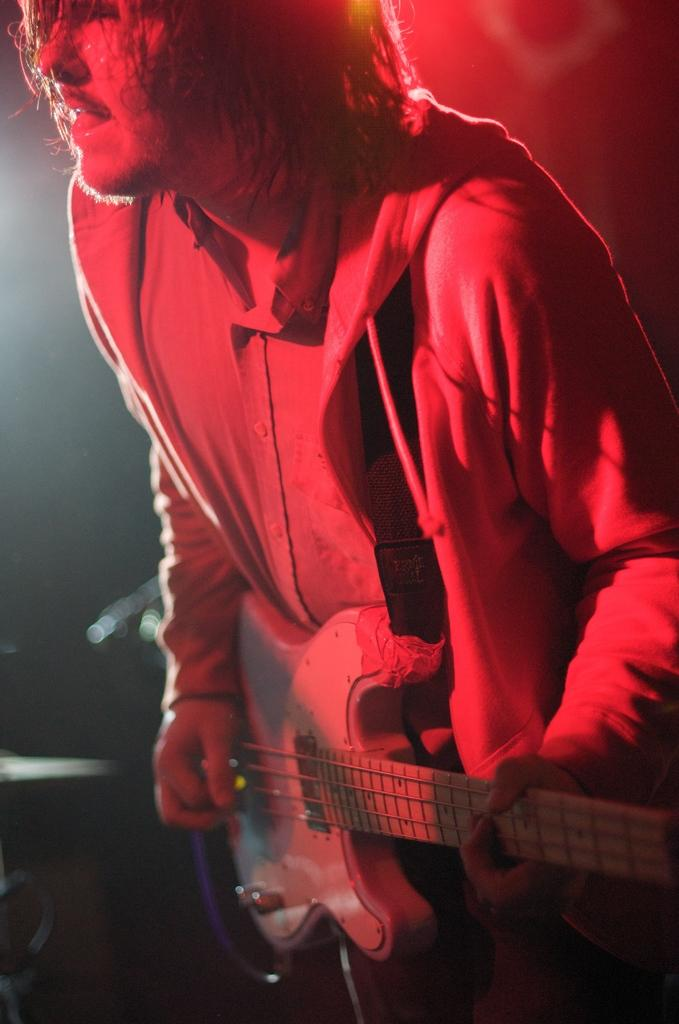What is the main subject of the image? There is a man in the image. What is the man doing in the image? The man is playing the guitar. What type of feather can be seen attached to the guitar in the image? There is no feather present or attached to the guitar in the image. Is the man driving a vehicle while playing the guitar in the image? No, the man is not driving a vehicle in the image; he is playing the guitar while standing or sitting. 